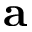<formula> <loc_0><loc_0><loc_500><loc_500>a</formula> 